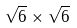Convert formula to latex. <formula><loc_0><loc_0><loc_500><loc_500>\sqrt { 6 } \times \sqrt { 6 }</formula> 